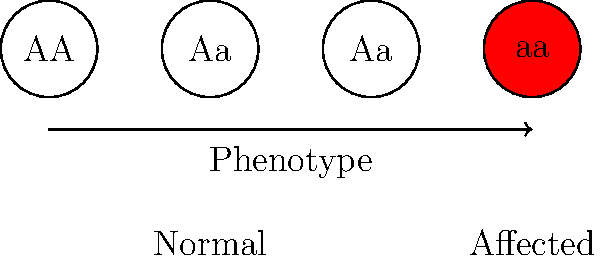Look at the diagram showing a genetic inheritance pattern. Which type of inheritance does this represent, and what is the probability of having an affected child if both parents are carriers (Aa)? To answer this question, let's analyze the diagram step-by-step:

1. The diagram shows four genotypes: AA, Aa, Aa, and aa.
2. Only the aa genotype is colored red, indicating it's the affected phenotype.
3. This pattern, where the trait is only expressed in the homozygous recessive state, represents autosomal recessive inheritance.

Now, let's calculate the probability of having an affected child if both parents are carriers (Aa):

1. We can use a Punnett square to visualize the possible outcomes:

   $$\begin{array}{c|c|c}
     & A & a \\
   \hline
   A & AA & Aa \\
   \hline
   a & Aa & aa
   \end{array}$$

2. From the Punnett square, we can see:
   - 1/4 chance of AA (unaffected)
   - 2/4 chance of Aa (carrier, unaffected)
   - 1/4 chance of aa (affected)

3. Therefore, the probability of having an affected child (aa) is 1/4 or 25%.
Answer: Autosomal recessive; 25% 